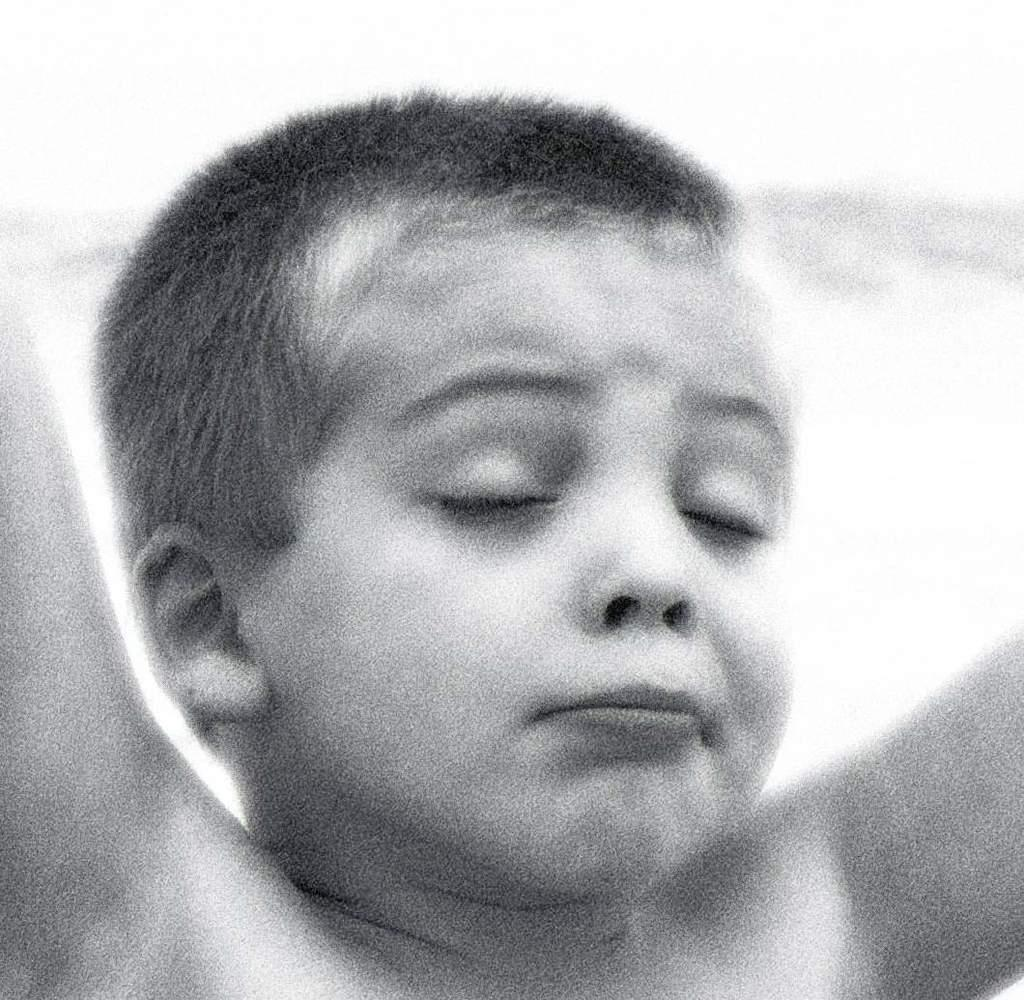Who is the main subject in the image? There is a boy in the image. What is the boy doing with his hands? The boy has his hands stretched out. What is the boy's facial expression in the image? The boy has his eyes closed. Can you describe the background of the image? The background of the image is blurred. How many sisters does the boy have in the image? There is no information about the boy's sisters in the image. What type of comb is the boy using in the image? There is no comb present in the image. 